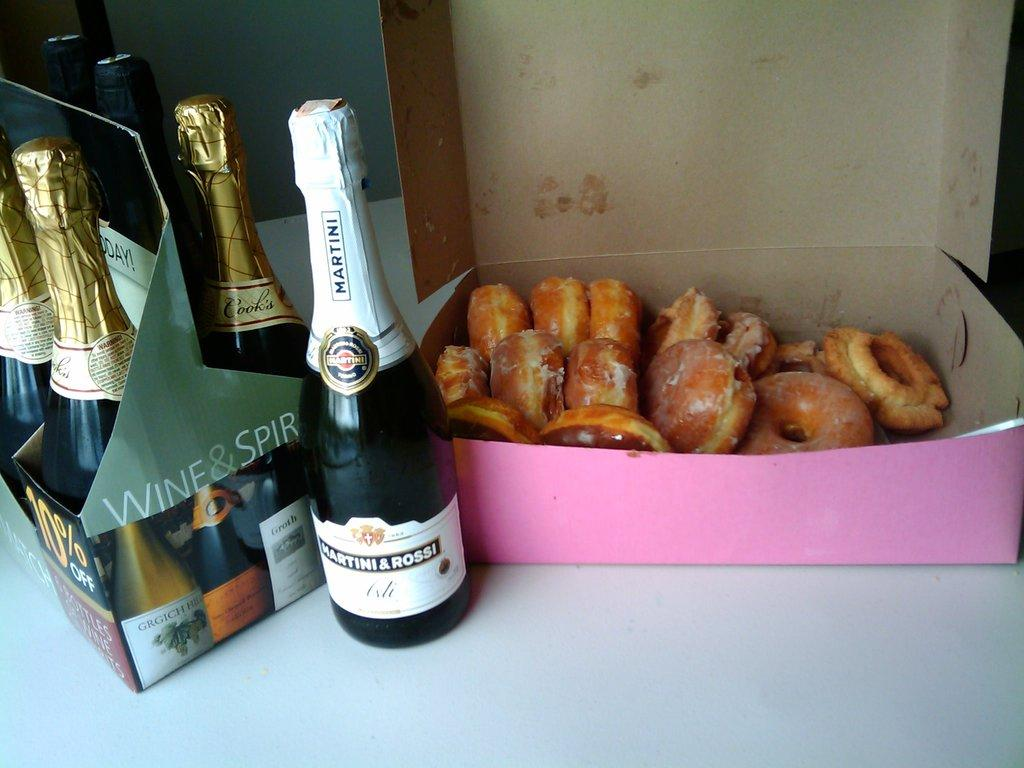What type of beverage containers are on the left side of the image? There are wine bottles on the left side of the image. What type of food is in the box on the right side of the image? There is a box containing donuts on the right side of the image. What type of shock can be seen on the donuts in the image? There is no shock present on the donuts in the image. How does the comb help in the image? There is no comb present in the image. 